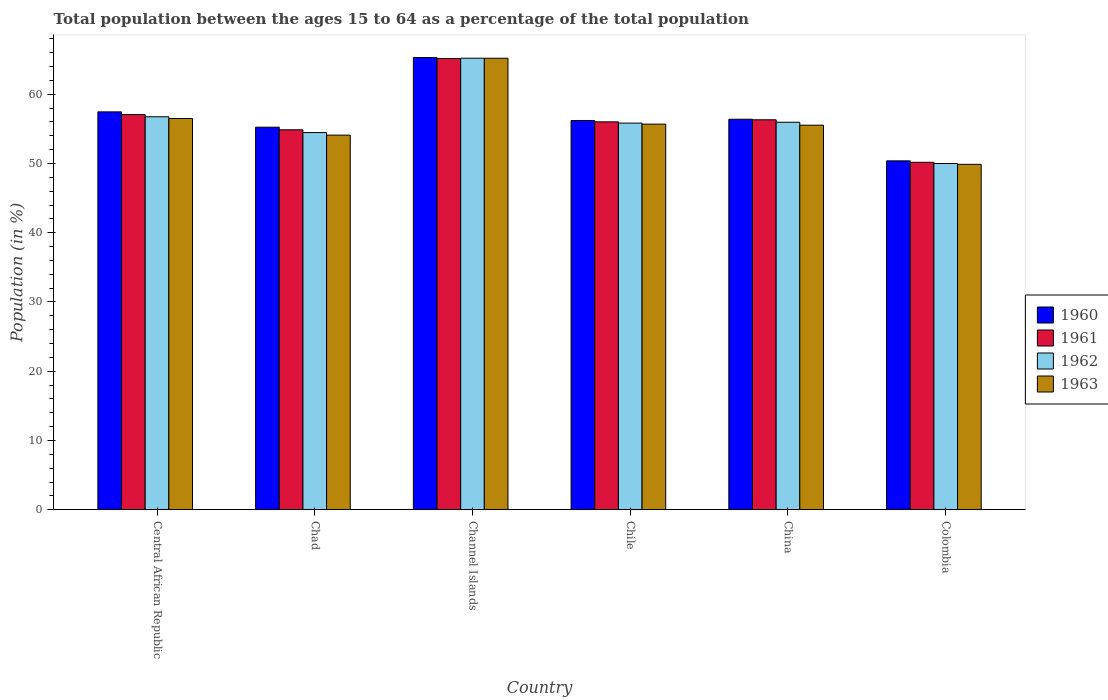How many groups of bars are there?
Keep it short and to the point. 6. Are the number of bars per tick equal to the number of legend labels?
Offer a terse response. Yes. Are the number of bars on each tick of the X-axis equal?
Ensure brevity in your answer.  Yes. How many bars are there on the 2nd tick from the right?
Offer a very short reply. 4. In how many cases, is the number of bars for a given country not equal to the number of legend labels?
Provide a succinct answer. 0. What is the percentage of the population ages 15 to 64 in 1961 in Chile?
Offer a terse response. 56.02. Across all countries, what is the maximum percentage of the population ages 15 to 64 in 1963?
Make the answer very short. 65.21. Across all countries, what is the minimum percentage of the population ages 15 to 64 in 1962?
Your answer should be compact. 50. In which country was the percentage of the population ages 15 to 64 in 1961 maximum?
Your answer should be compact. Channel Islands. In which country was the percentage of the population ages 15 to 64 in 1961 minimum?
Offer a terse response. Colombia. What is the total percentage of the population ages 15 to 64 in 1962 in the graph?
Provide a short and direct response. 338.23. What is the difference between the percentage of the population ages 15 to 64 in 1963 in Chad and that in Chile?
Your answer should be very brief. -1.59. What is the difference between the percentage of the population ages 15 to 64 in 1961 in China and the percentage of the population ages 15 to 64 in 1962 in Chad?
Offer a terse response. 1.85. What is the average percentage of the population ages 15 to 64 in 1963 per country?
Provide a short and direct response. 56.15. What is the difference between the percentage of the population ages 15 to 64 of/in 1960 and percentage of the population ages 15 to 64 of/in 1961 in Chile?
Your answer should be very brief. 0.2. What is the ratio of the percentage of the population ages 15 to 64 in 1962 in Central African Republic to that in Chad?
Your response must be concise. 1.04. Is the percentage of the population ages 15 to 64 in 1960 in Channel Islands less than that in China?
Keep it short and to the point. No. What is the difference between the highest and the second highest percentage of the population ages 15 to 64 in 1963?
Keep it short and to the point. -8.7. What is the difference between the highest and the lowest percentage of the population ages 15 to 64 in 1961?
Offer a very short reply. 14.99. Is it the case that in every country, the sum of the percentage of the population ages 15 to 64 in 1962 and percentage of the population ages 15 to 64 in 1963 is greater than the sum of percentage of the population ages 15 to 64 in 1960 and percentage of the population ages 15 to 64 in 1961?
Provide a short and direct response. No. What does the 2nd bar from the right in China represents?
Your answer should be very brief. 1962. How many bars are there?
Ensure brevity in your answer.  24. Are all the bars in the graph horizontal?
Your answer should be compact. No. How many countries are there in the graph?
Offer a very short reply. 6. What is the difference between two consecutive major ticks on the Y-axis?
Provide a short and direct response. 10. Are the values on the major ticks of Y-axis written in scientific E-notation?
Give a very brief answer. No. Does the graph contain grids?
Give a very brief answer. No. How many legend labels are there?
Make the answer very short. 4. How are the legend labels stacked?
Keep it short and to the point. Vertical. What is the title of the graph?
Your answer should be very brief. Total population between the ages 15 to 64 as a percentage of the total population. What is the label or title of the X-axis?
Keep it short and to the point. Country. What is the Population (in %) in 1960 in Central African Republic?
Offer a very short reply. 57.46. What is the Population (in %) in 1961 in Central African Republic?
Offer a very short reply. 57.07. What is the Population (in %) in 1962 in Central African Republic?
Your answer should be compact. 56.75. What is the Population (in %) in 1963 in Central African Republic?
Your answer should be very brief. 56.5. What is the Population (in %) in 1960 in Chad?
Keep it short and to the point. 55.25. What is the Population (in %) in 1961 in Chad?
Make the answer very short. 54.87. What is the Population (in %) in 1962 in Chad?
Provide a short and direct response. 54.47. What is the Population (in %) of 1963 in Chad?
Make the answer very short. 54.1. What is the Population (in %) in 1960 in Channel Islands?
Your answer should be compact. 65.31. What is the Population (in %) of 1961 in Channel Islands?
Make the answer very short. 65.17. What is the Population (in %) of 1962 in Channel Islands?
Your response must be concise. 65.21. What is the Population (in %) of 1963 in Channel Islands?
Your response must be concise. 65.21. What is the Population (in %) in 1960 in Chile?
Offer a very short reply. 56.21. What is the Population (in %) of 1961 in Chile?
Your answer should be very brief. 56.02. What is the Population (in %) in 1962 in Chile?
Keep it short and to the point. 55.84. What is the Population (in %) in 1963 in Chile?
Offer a terse response. 55.69. What is the Population (in %) in 1960 in China?
Offer a terse response. 56.39. What is the Population (in %) in 1961 in China?
Ensure brevity in your answer.  56.32. What is the Population (in %) in 1962 in China?
Provide a short and direct response. 55.96. What is the Population (in %) in 1963 in China?
Provide a succinct answer. 55.54. What is the Population (in %) of 1960 in Colombia?
Give a very brief answer. 50.39. What is the Population (in %) in 1961 in Colombia?
Offer a very short reply. 50.18. What is the Population (in %) in 1962 in Colombia?
Provide a short and direct response. 50. What is the Population (in %) of 1963 in Colombia?
Provide a succinct answer. 49.88. Across all countries, what is the maximum Population (in %) in 1960?
Your response must be concise. 65.31. Across all countries, what is the maximum Population (in %) in 1961?
Offer a terse response. 65.17. Across all countries, what is the maximum Population (in %) in 1962?
Your response must be concise. 65.21. Across all countries, what is the maximum Population (in %) of 1963?
Keep it short and to the point. 65.21. Across all countries, what is the minimum Population (in %) of 1960?
Provide a succinct answer. 50.39. Across all countries, what is the minimum Population (in %) of 1961?
Give a very brief answer. 50.18. Across all countries, what is the minimum Population (in %) in 1962?
Provide a succinct answer. 50. Across all countries, what is the minimum Population (in %) of 1963?
Make the answer very short. 49.88. What is the total Population (in %) in 1960 in the graph?
Offer a very short reply. 341.01. What is the total Population (in %) in 1961 in the graph?
Your answer should be very brief. 339.62. What is the total Population (in %) of 1962 in the graph?
Make the answer very short. 338.23. What is the total Population (in %) of 1963 in the graph?
Offer a terse response. 336.92. What is the difference between the Population (in %) of 1960 in Central African Republic and that in Chad?
Ensure brevity in your answer.  2.21. What is the difference between the Population (in %) of 1961 in Central African Republic and that in Chad?
Give a very brief answer. 2.2. What is the difference between the Population (in %) of 1962 in Central African Republic and that in Chad?
Ensure brevity in your answer.  2.28. What is the difference between the Population (in %) of 1963 in Central African Republic and that in Chad?
Offer a terse response. 2.4. What is the difference between the Population (in %) of 1960 in Central African Republic and that in Channel Islands?
Your response must be concise. -7.86. What is the difference between the Population (in %) of 1961 in Central African Republic and that in Channel Islands?
Offer a very short reply. -8.1. What is the difference between the Population (in %) in 1962 in Central African Republic and that in Channel Islands?
Your answer should be very brief. -8.46. What is the difference between the Population (in %) of 1963 in Central African Republic and that in Channel Islands?
Provide a succinct answer. -8.7. What is the difference between the Population (in %) in 1960 in Central African Republic and that in Chile?
Ensure brevity in your answer.  1.25. What is the difference between the Population (in %) in 1961 in Central African Republic and that in Chile?
Offer a terse response. 1.05. What is the difference between the Population (in %) of 1962 in Central African Republic and that in Chile?
Your response must be concise. 0.92. What is the difference between the Population (in %) of 1963 in Central African Republic and that in Chile?
Offer a terse response. 0.81. What is the difference between the Population (in %) of 1960 in Central African Republic and that in China?
Give a very brief answer. 1.07. What is the difference between the Population (in %) in 1961 in Central African Republic and that in China?
Your answer should be very brief. 0.75. What is the difference between the Population (in %) in 1962 in Central African Republic and that in China?
Keep it short and to the point. 0.79. What is the difference between the Population (in %) in 1963 in Central African Republic and that in China?
Keep it short and to the point. 0.97. What is the difference between the Population (in %) in 1960 in Central African Republic and that in Colombia?
Ensure brevity in your answer.  7.07. What is the difference between the Population (in %) of 1961 in Central African Republic and that in Colombia?
Ensure brevity in your answer.  6.89. What is the difference between the Population (in %) in 1962 in Central African Republic and that in Colombia?
Make the answer very short. 6.75. What is the difference between the Population (in %) in 1963 in Central African Republic and that in Colombia?
Ensure brevity in your answer.  6.62. What is the difference between the Population (in %) of 1960 in Chad and that in Channel Islands?
Make the answer very short. -10.07. What is the difference between the Population (in %) of 1961 in Chad and that in Channel Islands?
Offer a terse response. -10.3. What is the difference between the Population (in %) in 1962 in Chad and that in Channel Islands?
Ensure brevity in your answer.  -10.74. What is the difference between the Population (in %) of 1963 in Chad and that in Channel Islands?
Keep it short and to the point. -11.11. What is the difference between the Population (in %) in 1960 in Chad and that in Chile?
Provide a short and direct response. -0.97. What is the difference between the Population (in %) in 1961 in Chad and that in Chile?
Offer a very short reply. -1.15. What is the difference between the Population (in %) in 1962 in Chad and that in Chile?
Your answer should be very brief. -1.37. What is the difference between the Population (in %) of 1963 in Chad and that in Chile?
Your answer should be very brief. -1.59. What is the difference between the Population (in %) of 1960 in Chad and that in China?
Offer a very short reply. -1.15. What is the difference between the Population (in %) of 1961 in Chad and that in China?
Your response must be concise. -1.45. What is the difference between the Population (in %) in 1962 in Chad and that in China?
Your response must be concise. -1.49. What is the difference between the Population (in %) in 1963 in Chad and that in China?
Make the answer very short. -1.44. What is the difference between the Population (in %) in 1960 in Chad and that in Colombia?
Offer a very short reply. 4.86. What is the difference between the Population (in %) in 1961 in Chad and that in Colombia?
Keep it short and to the point. 4.69. What is the difference between the Population (in %) of 1962 in Chad and that in Colombia?
Provide a short and direct response. 4.47. What is the difference between the Population (in %) of 1963 in Chad and that in Colombia?
Your answer should be compact. 4.22. What is the difference between the Population (in %) in 1960 in Channel Islands and that in Chile?
Your answer should be very brief. 9.1. What is the difference between the Population (in %) of 1961 in Channel Islands and that in Chile?
Offer a terse response. 9.15. What is the difference between the Population (in %) of 1962 in Channel Islands and that in Chile?
Your answer should be compact. 9.37. What is the difference between the Population (in %) in 1963 in Channel Islands and that in Chile?
Your response must be concise. 9.52. What is the difference between the Population (in %) in 1960 in Channel Islands and that in China?
Offer a terse response. 8.92. What is the difference between the Population (in %) of 1961 in Channel Islands and that in China?
Keep it short and to the point. 8.86. What is the difference between the Population (in %) in 1962 in Channel Islands and that in China?
Provide a short and direct response. 9.25. What is the difference between the Population (in %) of 1963 in Channel Islands and that in China?
Your answer should be compact. 9.67. What is the difference between the Population (in %) of 1960 in Channel Islands and that in Colombia?
Offer a terse response. 14.93. What is the difference between the Population (in %) in 1961 in Channel Islands and that in Colombia?
Your answer should be very brief. 14.99. What is the difference between the Population (in %) in 1962 in Channel Islands and that in Colombia?
Your response must be concise. 15.21. What is the difference between the Population (in %) in 1963 in Channel Islands and that in Colombia?
Ensure brevity in your answer.  15.32. What is the difference between the Population (in %) in 1960 in Chile and that in China?
Ensure brevity in your answer.  -0.18. What is the difference between the Population (in %) in 1961 in Chile and that in China?
Give a very brief answer. -0.3. What is the difference between the Population (in %) of 1962 in Chile and that in China?
Make the answer very short. -0.13. What is the difference between the Population (in %) of 1963 in Chile and that in China?
Provide a succinct answer. 0.15. What is the difference between the Population (in %) of 1960 in Chile and that in Colombia?
Make the answer very short. 5.83. What is the difference between the Population (in %) of 1961 in Chile and that in Colombia?
Offer a terse response. 5.84. What is the difference between the Population (in %) in 1962 in Chile and that in Colombia?
Make the answer very short. 5.83. What is the difference between the Population (in %) of 1963 in Chile and that in Colombia?
Your answer should be very brief. 5.81. What is the difference between the Population (in %) of 1960 in China and that in Colombia?
Make the answer very short. 6.01. What is the difference between the Population (in %) of 1961 in China and that in Colombia?
Keep it short and to the point. 6.14. What is the difference between the Population (in %) in 1962 in China and that in Colombia?
Your response must be concise. 5.96. What is the difference between the Population (in %) in 1963 in China and that in Colombia?
Offer a terse response. 5.65. What is the difference between the Population (in %) of 1960 in Central African Republic and the Population (in %) of 1961 in Chad?
Provide a succinct answer. 2.59. What is the difference between the Population (in %) in 1960 in Central African Republic and the Population (in %) in 1962 in Chad?
Your answer should be very brief. 2.99. What is the difference between the Population (in %) of 1960 in Central African Republic and the Population (in %) of 1963 in Chad?
Make the answer very short. 3.36. What is the difference between the Population (in %) in 1961 in Central African Republic and the Population (in %) in 1962 in Chad?
Your answer should be compact. 2.6. What is the difference between the Population (in %) of 1961 in Central African Republic and the Population (in %) of 1963 in Chad?
Give a very brief answer. 2.97. What is the difference between the Population (in %) in 1962 in Central African Republic and the Population (in %) in 1963 in Chad?
Your response must be concise. 2.65. What is the difference between the Population (in %) of 1960 in Central African Republic and the Population (in %) of 1961 in Channel Islands?
Your answer should be compact. -7.71. What is the difference between the Population (in %) in 1960 in Central African Republic and the Population (in %) in 1962 in Channel Islands?
Provide a succinct answer. -7.75. What is the difference between the Population (in %) in 1960 in Central African Republic and the Population (in %) in 1963 in Channel Islands?
Your answer should be compact. -7.75. What is the difference between the Population (in %) of 1961 in Central African Republic and the Population (in %) of 1962 in Channel Islands?
Offer a terse response. -8.14. What is the difference between the Population (in %) of 1961 in Central African Republic and the Population (in %) of 1963 in Channel Islands?
Keep it short and to the point. -8.14. What is the difference between the Population (in %) of 1962 in Central African Republic and the Population (in %) of 1963 in Channel Islands?
Your answer should be compact. -8.45. What is the difference between the Population (in %) in 1960 in Central African Republic and the Population (in %) in 1961 in Chile?
Give a very brief answer. 1.44. What is the difference between the Population (in %) in 1960 in Central African Republic and the Population (in %) in 1962 in Chile?
Offer a very short reply. 1.62. What is the difference between the Population (in %) of 1960 in Central African Republic and the Population (in %) of 1963 in Chile?
Provide a short and direct response. 1.77. What is the difference between the Population (in %) of 1961 in Central African Republic and the Population (in %) of 1962 in Chile?
Provide a succinct answer. 1.23. What is the difference between the Population (in %) in 1961 in Central African Republic and the Population (in %) in 1963 in Chile?
Keep it short and to the point. 1.38. What is the difference between the Population (in %) of 1962 in Central African Republic and the Population (in %) of 1963 in Chile?
Offer a terse response. 1.06. What is the difference between the Population (in %) in 1960 in Central African Republic and the Population (in %) in 1961 in China?
Your answer should be very brief. 1.14. What is the difference between the Population (in %) in 1960 in Central African Republic and the Population (in %) in 1962 in China?
Offer a terse response. 1.5. What is the difference between the Population (in %) in 1960 in Central African Republic and the Population (in %) in 1963 in China?
Ensure brevity in your answer.  1.92. What is the difference between the Population (in %) of 1961 in Central African Republic and the Population (in %) of 1962 in China?
Ensure brevity in your answer.  1.11. What is the difference between the Population (in %) in 1961 in Central African Republic and the Population (in %) in 1963 in China?
Ensure brevity in your answer.  1.53. What is the difference between the Population (in %) in 1962 in Central African Republic and the Population (in %) in 1963 in China?
Your answer should be very brief. 1.22. What is the difference between the Population (in %) of 1960 in Central African Republic and the Population (in %) of 1961 in Colombia?
Ensure brevity in your answer.  7.28. What is the difference between the Population (in %) of 1960 in Central African Republic and the Population (in %) of 1962 in Colombia?
Provide a short and direct response. 7.46. What is the difference between the Population (in %) of 1960 in Central African Republic and the Population (in %) of 1963 in Colombia?
Your answer should be very brief. 7.58. What is the difference between the Population (in %) of 1961 in Central African Republic and the Population (in %) of 1962 in Colombia?
Provide a short and direct response. 7.07. What is the difference between the Population (in %) in 1961 in Central African Republic and the Population (in %) in 1963 in Colombia?
Provide a succinct answer. 7.19. What is the difference between the Population (in %) of 1962 in Central African Republic and the Population (in %) of 1963 in Colombia?
Ensure brevity in your answer.  6.87. What is the difference between the Population (in %) of 1960 in Chad and the Population (in %) of 1961 in Channel Islands?
Provide a succinct answer. -9.93. What is the difference between the Population (in %) of 1960 in Chad and the Population (in %) of 1962 in Channel Islands?
Offer a terse response. -9.97. What is the difference between the Population (in %) in 1960 in Chad and the Population (in %) in 1963 in Channel Islands?
Your response must be concise. -9.96. What is the difference between the Population (in %) of 1961 in Chad and the Population (in %) of 1962 in Channel Islands?
Keep it short and to the point. -10.34. What is the difference between the Population (in %) in 1961 in Chad and the Population (in %) in 1963 in Channel Islands?
Offer a very short reply. -10.34. What is the difference between the Population (in %) in 1962 in Chad and the Population (in %) in 1963 in Channel Islands?
Give a very brief answer. -10.74. What is the difference between the Population (in %) in 1960 in Chad and the Population (in %) in 1961 in Chile?
Provide a succinct answer. -0.77. What is the difference between the Population (in %) of 1960 in Chad and the Population (in %) of 1962 in Chile?
Offer a terse response. -0.59. What is the difference between the Population (in %) of 1960 in Chad and the Population (in %) of 1963 in Chile?
Your response must be concise. -0.44. What is the difference between the Population (in %) of 1961 in Chad and the Population (in %) of 1962 in Chile?
Give a very brief answer. -0.97. What is the difference between the Population (in %) of 1961 in Chad and the Population (in %) of 1963 in Chile?
Give a very brief answer. -0.82. What is the difference between the Population (in %) of 1962 in Chad and the Population (in %) of 1963 in Chile?
Keep it short and to the point. -1.22. What is the difference between the Population (in %) of 1960 in Chad and the Population (in %) of 1961 in China?
Offer a very short reply. -1.07. What is the difference between the Population (in %) of 1960 in Chad and the Population (in %) of 1962 in China?
Ensure brevity in your answer.  -0.72. What is the difference between the Population (in %) in 1960 in Chad and the Population (in %) in 1963 in China?
Make the answer very short. -0.29. What is the difference between the Population (in %) of 1961 in Chad and the Population (in %) of 1962 in China?
Provide a short and direct response. -1.09. What is the difference between the Population (in %) in 1961 in Chad and the Population (in %) in 1963 in China?
Give a very brief answer. -0.67. What is the difference between the Population (in %) in 1962 in Chad and the Population (in %) in 1963 in China?
Give a very brief answer. -1.07. What is the difference between the Population (in %) in 1960 in Chad and the Population (in %) in 1961 in Colombia?
Keep it short and to the point. 5.07. What is the difference between the Population (in %) of 1960 in Chad and the Population (in %) of 1962 in Colombia?
Offer a very short reply. 5.24. What is the difference between the Population (in %) of 1960 in Chad and the Population (in %) of 1963 in Colombia?
Provide a short and direct response. 5.36. What is the difference between the Population (in %) in 1961 in Chad and the Population (in %) in 1962 in Colombia?
Offer a terse response. 4.87. What is the difference between the Population (in %) in 1961 in Chad and the Population (in %) in 1963 in Colombia?
Offer a terse response. 4.99. What is the difference between the Population (in %) of 1962 in Chad and the Population (in %) of 1963 in Colombia?
Keep it short and to the point. 4.59. What is the difference between the Population (in %) in 1960 in Channel Islands and the Population (in %) in 1961 in Chile?
Offer a terse response. 9.3. What is the difference between the Population (in %) in 1960 in Channel Islands and the Population (in %) in 1962 in Chile?
Keep it short and to the point. 9.48. What is the difference between the Population (in %) of 1960 in Channel Islands and the Population (in %) of 1963 in Chile?
Keep it short and to the point. 9.62. What is the difference between the Population (in %) of 1961 in Channel Islands and the Population (in %) of 1962 in Chile?
Offer a terse response. 9.34. What is the difference between the Population (in %) of 1961 in Channel Islands and the Population (in %) of 1963 in Chile?
Offer a very short reply. 9.48. What is the difference between the Population (in %) in 1962 in Channel Islands and the Population (in %) in 1963 in Chile?
Offer a terse response. 9.52. What is the difference between the Population (in %) of 1960 in Channel Islands and the Population (in %) of 1961 in China?
Keep it short and to the point. 9. What is the difference between the Population (in %) in 1960 in Channel Islands and the Population (in %) in 1962 in China?
Provide a short and direct response. 9.35. What is the difference between the Population (in %) of 1960 in Channel Islands and the Population (in %) of 1963 in China?
Offer a terse response. 9.78. What is the difference between the Population (in %) of 1961 in Channel Islands and the Population (in %) of 1962 in China?
Make the answer very short. 9.21. What is the difference between the Population (in %) of 1961 in Channel Islands and the Population (in %) of 1963 in China?
Your answer should be very brief. 9.64. What is the difference between the Population (in %) in 1962 in Channel Islands and the Population (in %) in 1963 in China?
Give a very brief answer. 9.68. What is the difference between the Population (in %) in 1960 in Channel Islands and the Population (in %) in 1961 in Colombia?
Provide a succinct answer. 15.14. What is the difference between the Population (in %) of 1960 in Channel Islands and the Population (in %) of 1962 in Colombia?
Give a very brief answer. 15.31. What is the difference between the Population (in %) of 1960 in Channel Islands and the Population (in %) of 1963 in Colombia?
Your response must be concise. 15.43. What is the difference between the Population (in %) in 1961 in Channel Islands and the Population (in %) in 1962 in Colombia?
Ensure brevity in your answer.  15.17. What is the difference between the Population (in %) in 1961 in Channel Islands and the Population (in %) in 1963 in Colombia?
Provide a short and direct response. 15.29. What is the difference between the Population (in %) in 1962 in Channel Islands and the Population (in %) in 1963 in Colombia?
Give a very brief answer. 15.33. What is the difference between the Population (in %) of 1960 in Chile and the Population (in %) of 1961 in China?
Make the answer very short. -0.1. What is the difference between the Population (in %) of 1960 in Chile and the Population (in %) of 1962 in China?
Your answer should be very brief. 0.25. What is the difference between the Population (in %) in 1960 in Chile and the Population (in %) in 1963 in China?
Keep it short and to the point. 0.68. What is the difference between the Population (in %) in 1961 in Chile and the Population (in %) in 1962 in China?
Ensure brevity in your answer.  0.06. What is the difference between the Population (in %) of 1961 in Chile and the Population (in %) of 1963 in China?
Your response must be concise. 0.48. What is the difference between the Population (in %) in 1962 in Chile and the Population (in %) in 1963 in China?
Your answer should be compact. 0.3. What is the difference between the Population (in %) in 1960 in Chile and the Population (in %) in 1961 in Colombia?
Make the answer very short. 6.04. What is the difference between the Population (in %) in 1960 in Chile and the Population (in %) in 1962 in Colombia?
Ensure brevity in your answer.  6.21. What is the difference between the Population (in %) in 1960 in Chile and the Population (in %) in 1963 in Colombia?
Keep it short and to the point. 6.33. What is the difference between the Population (in %) of 1961 in Chile and the Population (in %) of 1962 in Colombia?
Make the answer very short. 6.02. What is the difference between the Population (in %) in 1961 in Chile and the Population (in %) in 1963 in Colombia?
Provide a succinct answer. 6.14. What is the difference between the Population (in %) in 1962 in Chile and the Population (in %) in 1963 in Colombia?
Keep it short and to the point. 5.96. What is the difference between the Population (in %) in 1960 in China and the Population (in %) in 1961 in Colombia?
Your answer should be very brief. 6.22. What is the difference between the Population (in %) in 1960 in China and the Population (in %) in 1962 in Colombia?
Provide a succinct answer. 6.39. What is the difference between the Population (in %) of 1960 in China and the Population (in %) of 1963 in Colombia?
Ensure brevity in your answer.  6.51. What is the difference between the Population (in %) in 1961 in China and the Population (in %) in 1962 in Colombia?
Offer a very short reply. 6.31. What is the difference between the Population (in %) of 1961 in China and the Population (in %) of 1963 in Colombia?
Keep it short and to the point. 6.44. What is the difference between the Population (in %) in 1962 in China and the Population (in %) in 1963 in Colombia?
Offer a very short reply. 6.08. What is the average Population (in %) in 1960 per country?
Ensure brevity in your answer.  56.84. What is the average Population (in %) of 1961 per country?
Offer a terse response. 56.6. What is the average Population (in %) in 1962 per country?
Provide a short and direct response. 56.37. What is the average Population (in %) in 1963 per country?
Provide a succinct answer. 56.15. What is the difference between the Population (in %) in 1960 and Population (in %) in 1961 in Central African Republic?
Provide a succinct answer. 0.39. What is the difference between the Population (in %) of 1960 and Population (in %) of 1962 in Central African Republic?
Ensure brevity in your answer.  0.71. What is the difference between the Population (in %) of 1960 and Population (in %) of 1963 in Central African Republic?
Ensure brevity in your answer.  0.96. What is the difference between the Population (in %) in 1961 and Population (in %) in 1962 in Central African Republic?
Offer a very short reply. 0.32. What is the difference between the Population (in %) of 1961 and Population (in %) of 1963 in Central African Republic?
Ensure brevity in your answer.  0.56. What is the difference between the Population (in %) in 1962 and Population (in %) in 1963 in Central African Republic?
Give a very brief answer. 0.25. What is the difference between the Population (in %) in 1960 and Population (in %) in 1961 in Chad?
Your answer should be compact. 0.38. What is the difference between the Population (in %) of 1960 and Population (in %) of 1962 in Chad?
Provide a short and direct response. 0.78. What is the difference between the Population (in %) in 1960 and Population (in %) in 1963 in Chad?
Your answer should be compact. 1.15. What is the difference between the Population (in %) in 1961 and Population (in %) in 1962 in Chad?
Provide a succinct answer. 0.4. What is the difference between the Population (in %) of 1961 and Population (in %) of 1963 in Chad?
Provide a succinct answer. 0.77. What is the difference between the Population (in %) of 1962 and Population (in %) of 1963 in Chad?
Provide a succinct answer. 0.37. What is the difference between the Population (in %) of 1960 and Population (in %) of 1961 in Channel Islands?
Your answer should be very brief. 0.14. What is the difference between the Population (in %) in 1960 and Population (in %) in 1962 in Channel Islands?
Your response must be concise. 0.1. What is the difference between the Population (in %) in 1960 and Population (in %) in 1963 in Channel Islands?
Your answer should be very brief. 0.11. What is the difference between the Population (in %) of 1961 and Population (in %) of 1962 in Channel Islands?
Provide a succinct answer. -0.04. What is the difference between the Population (in %) of 1961 and Population (in %) of 1963 in Channel Islands?
Your response must be concise. -0.03. What is the difference between the Population (in %) of 1962 and Population (in %) of 1963 in Channel Islands?
Your answer should be very brief. 0. What is the difference between the Population (in %) of 1960 and Population (in %) of 1961 in Chile?
Make the answer very short. 0.2. What is the difference between the Population (in %) of 1960 and Population (in %) of 1962 in Chile?
Provide a succinct answer. 0.38. What is the difference between the Population (in %) in 1960 and Population (in %) in 1963 in Chile?
Offer a terse response. 0.52. What is the difference between the Population (in %) of 1961 and Population (in %) of 1962 in Chile?
Offer a terse response. 0.18. What is the difference between the Population (in %) in 1961 and Population (in %) in 1963 in Chile?
Your answer should be very brief. 0.33. What is the difference between the Population (in %) in 1962 and Population (in %) in 1963 in Chile?
Make the answer very short. 0.15. What is the difference between the Population (in %) of 1960 and Population (in %) of 1961 in China?
Ensure brevity in your answer.  0.08. What is the difference between the Population (in %) in 1960 and Population (in %) in 1962 in China?
Provide a short and direct response. 0.43. What is the difference between the Population (in %) in 1960 and Population (in %) in 1963 in China?
Offer a terse response. 0.86. What is the difference between the Population (in %) in 1961 and Population (in %) in 1962 in China?
Offer a very short reply. 0.35. What is the difference between the Population (in %) in 1961 and Population (in %) in 1963 in China?
Your answer should be very brief. 0.78. What is the difference between the Population (in %) of 1962 and Population (in %) of 1963 in China?
Make the answer very short. 0.43. What is the difference between the Population (in %) of 1960 and Population (in %) of 1961 in Colombia?
Make the answer very short. 0.21. What is the difference between the Population (in %) of 1960 and Population (in %) of 1962 in Colombia?
Your answer should be compact. 0.38. What is the difference between the Population (in %) of 1960 and Population (in %) of 1963 in Colombia?
Your response must be concise. 0.5. What is the difference between the Population (in %) in 1961 and Population (in %) in 1962 in Colombia?
Offer a terse response. 0.17. What is the difference between the Population (in %) in 1961 and Population (in %) in 1963 in Colombia?
Make the answer very short. 0.3. What is the difference between the Population (in %) in 1962 and Population (in %) in 1963 in Colombia?
Ensure brevity in your answer.  0.12. What is the ratio of the Population (in %) of 1960 in Central African Republic to that in Chad?
Provide a short and direct response. 1.04. What is the ratio of the Population (in %) of 1961 in Central African Republic to that in Chad?
Provide a succinct answer. 1.04. What is the ratio of the Population (in %) of 1962 in Central African Republic to that in Chad?
Keep it short and to the point. 1.04. What is the ratio of the Population (in %) in 1963 in Central African Republic to that in Chad?
Make the answer very short. 1.04. What is the ratio of the Population (in %) in 1960 in Central African Republic to that in Channel Islands?
Provide a succinct answer. 0.88. What is the ratio of the Population (in %) in 1961 in Central African Republic to that in Channel Islands?
Make the answer very short. 0.88. What is the ratio of the Population (in %) of 1962 in Central African Republic to that in Channel Islands?
Make the answer very short. 0.87. What is the ratio of the Population (in %) of 1963 in Central African Republic to that in Channel Islands?
Your response must be concise. 0.87. What is the ratio of the Population (in %) in 1960 in Central African Republic to that in Chile?
Offer a very short reply. 1.02. What is the ratio of the Population (in %) in 1961 in Central African Republic to that in Chile?
Your response must be concise. 1.02. What is the ratio of the Population (in %) of 1962 in Central African Republic to that in Chile?
Your response must be concise. 1.02. What is the ratio of the Population (in %) in 1963 in Central African Republic to that in Chile?
Provide a succinct answer. 1.01. What is the ratio of the Population (in %) in 1960 in Central African Republic to that in China?
Offer a terse response. 1.02. What is the ratio of the Population (in %) of 1961 in Central African Republic to that in China?
Your response must be concise. 1.01. What is the ratio of the Population (in %) of 1962 in Central African Republic to that in China?
Your response must be concise. 1.01. What is the ratio of the Population (in %) in 1963 in Central African Republic to that in China?
Give a very brief answer. 1.02. What is the ratio of the Population (in %) in 1960 in Central African Republic to that in Colombia?
Your answer should be very brief. 1.14. What is the ratio of the Population (in %) in 1961 in Central African Republic to that in Colombia?
Ensure brevity in your answer.  1.14. What is the ratio of the Population (in %) of 1962 in Central African Republic to that in Colombia?
Provide a short and direct response. 1.14. What is the ratio of the Population (in %) in 1963 in Central African Republic to that in Colombia?
Offer a terse response. 1.13. What is the ratio of the Population (in %) of 1960 in Chad to that in Channel Islands?
Your response must be concise. 0.85. What is the ratio of the Population (in %) in 1961 in Chad to that in Channel Islands?
Provide a short and direct response. 0.84. What is the ratio of the Population (in %) in 1962 in Chad to that in Channel Islands?
Your answer should be compact. 0.84. What is the ratio of the Population (in %) in 1963 in Chad to that in Channel Islands?
Provide a short and direct response. 0.83. What is the ratio of the Population (in %) in 1960 in Chad to that in Chile?
Make the answer very short. 0.98. What is the ratio of the Population (in %) in 1961 in Chad to that in Chile?
Keep it short and to the point. 0.98. What is the ratio of the Population (in %) of 1962 in Chad to that in Chile?
Your response must be concise. 0.98. What is the ratio of the Population (in %) in 1963 in Chad to that in Chile?
Keep it short and to the point. 0.97. What is the ratio of the Population (in %) in 1960 in Chad to that in China?
Offer a very short reply. 0.98. What is the ratio of the Population (in %) of 1961 in Chad to that in China?
Your response must be concise. 0.97. What is the ratio of the Population (in %) in 1962 in Chad to that in China?
Offer a terse response. 0.97. What is the ratio of the Population (in %) in 1963 in Chad to that in China?
Make the answer very short. 0.97. What is the ratio of the Population (in %) of 1960 in Chad to that in Colombia?
Your response must be concise. 1.1. What is the ratio of the Population (in %) of 1961 in Chad to that in Colombia?
Ensure brevity in your answer.  1.09. What is the ratio of the Population (in %) of 1962 in Chad to that in Colombia?
Offer a terse response. 1.09. What is the ratio of the Population (in %) in 1963 in Chad to that in Colombia?
Ensure brevity in your answer.  1.08. What is the ratio of the Population (in %) in 1960 in Channel Islands to that in Chile?
Ensure brevity in your answer.  1.16. What is the ratio of the Population (in %) of 1961 in Channel Islands to that in Chile?
Your response must be concise. 1.16. What is the ratio of the Population (in %) in 1962 in Channel Islands to that in Chile?
Give a very brief answer. 1.17. What is the ratio of the Population (in %) of 1963 in Channel Islands to that in Chile?
Provide a succinct answer. 1.17. What is the ratio of the Population (in %) of 1960 in Channel Islands to that in China?
Keep it short and to the point. 1.16. What is the ratio of the Population (in %) of 1961 in Channel Islands to that in China?
Make the answer very short. 1.16. What is the ratio of the Population (in %) of 1962 in Channel Islands to that in China?
Your answer should be compact. 1.17. What is the ratio of the Population (in %) in 1963 in Channel Islands to that in China?
Your answer should be very brief. 1.17. What is the ratio of the Population (in %) of 1960 in Channel Islands to that in Colombia?
Make the answer very short. 1.3. What is the ratio of the Population (in %) in 1961 in Channel Islands to that in Colombia?
Make the answer very short. 1.3. What is the ratio of the Population (in %) of 1962 in Channel Islands to that in Colombia?
Provide a succinct answer. 1.3. What is the ratio of the Population (in %) in 1963 in Channel Islands to that in Colombia?
Ensure brevity in your answer.  1.31. What is the ratio of the Population (in %) in 1960 in Chile to that in China?
Ensure brevity in your answer.  1. What is the ratio of the Population (in %) in 1960 in Chile to that in Colombia?
Make the answer very short. 1.12. What is the ratio of the Population (in %) of 1961 in Chile to that in Colombia?
Offer a very short reply. 1.12. What is the ratio of the Population (in %) in 1962 in Chile to that in Colombia?
Your response must be concise. 1.12. What is the ratio of the Population (in %) of 1963 in Chile to that in Colombia?
Offer a very short reply. 1.12. What is the ratio of the Population (in %) of 1960 in China to that in Colombia?
Keep it short and to the point. 1.12. What is the ratio of the Population (in %) of 1961 in China to that in Colombia?
Keep it short and to the point. 1.12. What is the ratio of the Population (in %) in 1962 in China to that in Colombia?
Provide a succinct answer. 1.12. What is the ratio of the Population (in %) of 1963 in China to that in Colombia?
Offer a very short reply. 1.11. What is the difference between the highest and the second highest Population (in %) in 1960?
Provide a succinct answer. 7.86. What is the difference between the highest and the second highest Population (in %) of 1961?
Ensure brevity in your answer.  8.1. What is the difference between the highest and the second highest Population (in %) in 1962?
Make the answer very short. 8.46. What is the difference between the highest and the second highest Population (in %) of 1963?
Your answer should be very brief. 8.7. What is the difference between the highest and the lowest Population (in %) of 1960?
Provide a succinct answer. 14.93. What is the difference between the highest and the lowest Population (in %) in 1961?
Offer a very short reply. 14.99. What is the difference between the highest and the lowest Population (in %) of 1962?
Your response must be concise. 15.21. What is the difference between the highest and the lowest Population (in %) of 1963?
Ensure brevity in your answer.  15.32. 